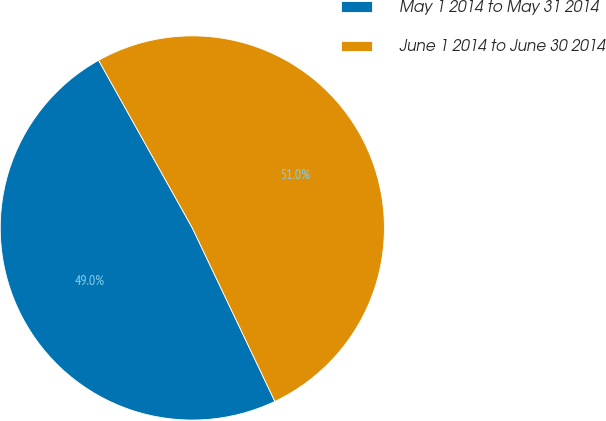<chart> <loc_0><loc_0><loc_500><loc_500><pie_chart><fcel>May 1 2014 to May 31 2014<fcel>June 1 2014 to June 30 2014<nl><fcel>48.96%<fcel>51.04%<nl></chart> 